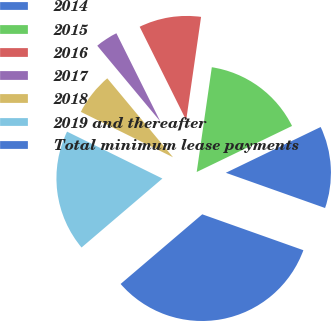<chart> <loc_0><loc_0><loc_500><loc_500><pie_chart><fcel>2014<fcel>2015<fcel>2016<fcel>2017<fcel>2018<fcel>2019 and thereafter<fcel>Total minimum lease payments<nl><fcel>12.59%<fcel>15.56%<fcel>9.63%<fcel>3.7%<fcel>6.67%<fcel>18.52%<fcel>33.33%<nl></chart> 